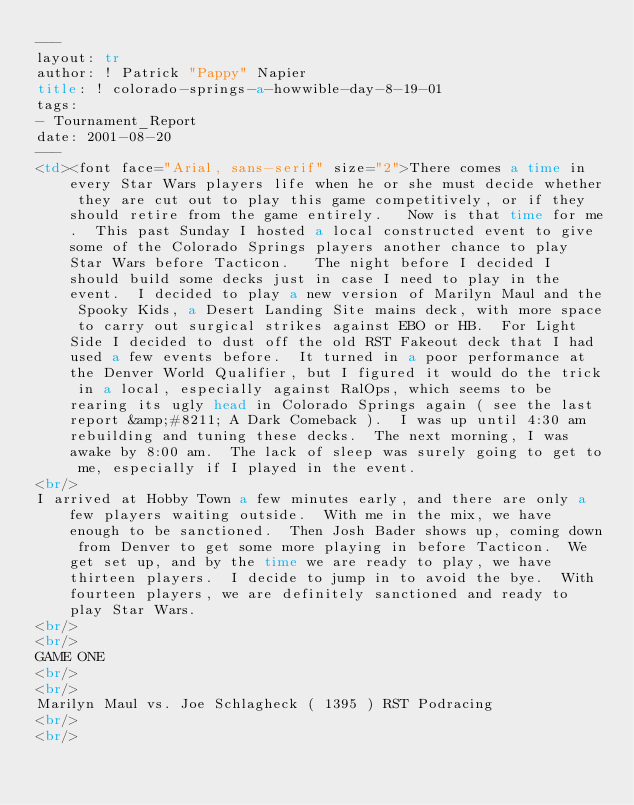<code> <loc_0><loc_0><loc_500><loc_500><_HTML_>---
layout: tr
author: ! Patrick "Pappy" Napier
title: ! colorado-springs-a-howwible-day-8-19-01
tags:
- Tournament_Report
date: 2001-08-20
---
<td><font face="Arial, sans-serif" size="2">There comes a time in every Star Wars players life when he or she must decide whether they are cut out to play this game competitively, or if they should retire from the game entirely.   Now is that time for me.  This past Sunday I hosted a local constructed event to give some of the Colorado Springs players another chance to play Star Wars before Tacticon.   The night before I decided I should build some decks just in case I need to play in the event.  I decided to play a new version of Marilyn Maul and the Spooky Kids, a Desert Landing Site mains deck, with more space to carry out surgical strikes against EBO or HB.  For Light Side I decided to dust off the old RST Fakeout deck that I had used a few events before.  It turned in a poor performance at the Denver World Qualifier, but I figured it would do the trick in a local, especially against RalOps, which seems to be rearing its ugly head in Colorado Springs again ( see the last report &amp;#8211; A Dark Comeback ).  I was up until 4:30 am rebuilding and tuning these decks.  The next morning, I was awake by 8:00 am.  The lack of sleep was surely going to get to me, especially if I played in the event.   <br/>
I arrived at Hobby Town a few minutes early, and there are only a few players waiting outside.  With me in the mix, we have enough to be sanctioned.  Then Josh Bader shows up, coming down from Denver to get some more playing in before Tacticon.  We get set up, and by the time we are ready to play, we have thirteen players.  I decide to jump in to avoid the bye.  With fourteen players, we are definitely sanctioned and ready to play Star Wars. <br/>
<br/>
GAME ONE <br/>
<br/>
Marilyn Maul vs. Joe Schlagheck ( 1395 ) RST Podracing<br/>
<br/></code> 